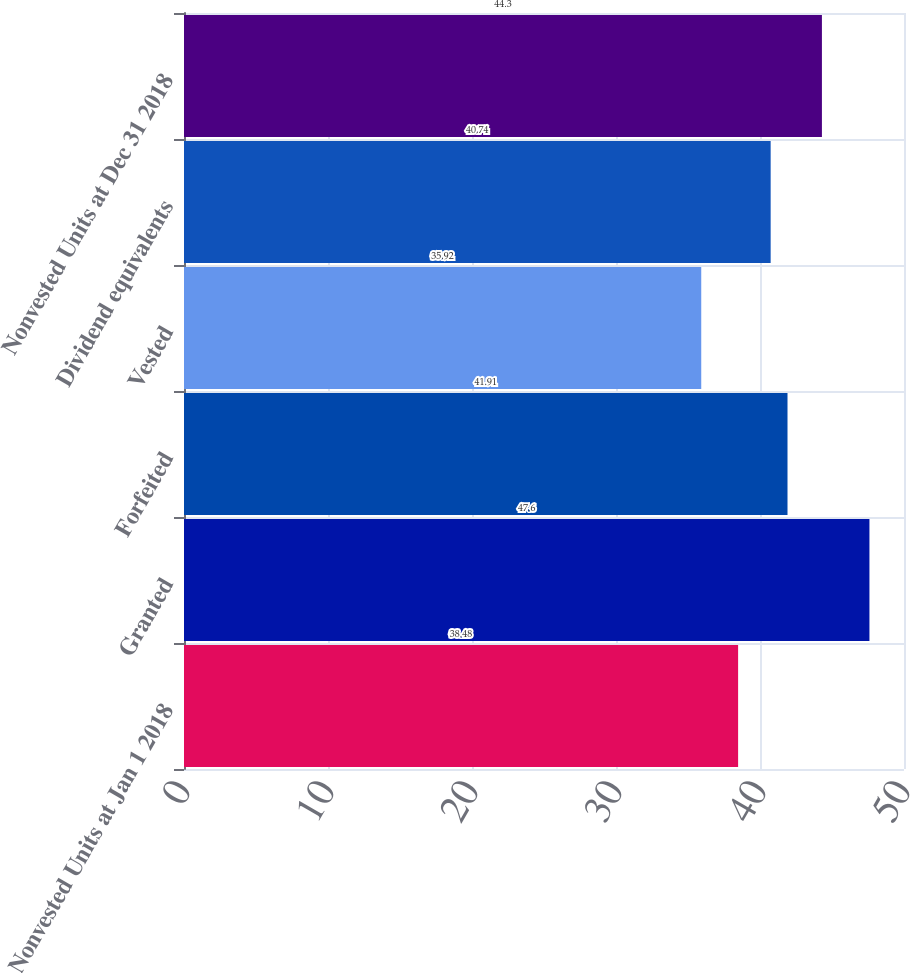Convert chart to OTSL. <chart><loc_0><loc_0><loc_500><loc_500><bar_chart><fcel>Nonvested Units at Jan 1 2018<fcel>Granted<fcel>Forfeited<fcel>Vested<fcel>Dividend equivalents<fcel>Nonvested Units at Dec 31 2018<nl><fcel>38.48<fcel>47.6<fcel>41.91<fcel>35.92<fcel>40.74<fcel>44.3<nl></chart> 